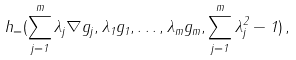<formula> <loc_0><loc_0><loc_500><loc_500>h _ { = } ( \sum _ { j = 1 } ^ { m } \lambda _ { j } \nabla g _ { j } , \lambda _ { 1 } g _ { 1 } , \dots , \lambda _ { m } g _ { m } , \sum _ { j = 1 } ^ { m } \lambda _ { j } ^ { 2 } - 1 ) \, ,</formula> 